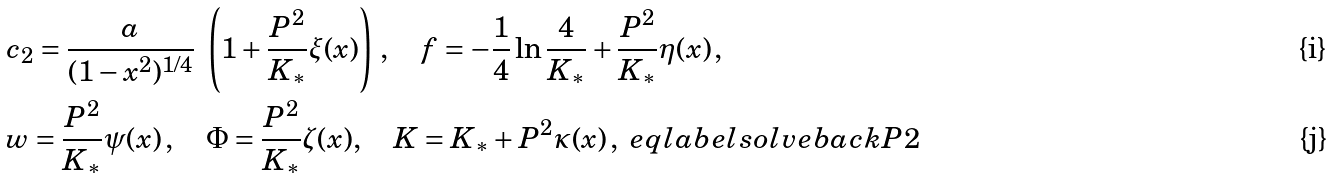<formula> <loc_0><loc_0><loc_500><loc_500>& c _ { 2 } = \frac { a } { ( 1 - x ^ { 2 } ) ^ { 1 / 4 } } \ \left ( 1 + \frac { P ^ { 2 } } { K _ { * } } \xi ( x ) \right ) \, , \quad f = - \frac { 1 } { 4 } \ln \frac { 4 } { K _ { * } } + \frac { P ^ { 2 } } { K _ { * } } \eta ( x ) \, , \\ & w = \frac { P ^ { 2 } } { K _ { * } } \psi ( x ) \, , \quad \Phi = \frac { P ^ { 2 } } { K _ { * } } \zeta ( x ) , \quad K = K _ { * } + P ^ { 2 } \kappa ( x ) \, , \ e q l a b e l { s o l v e b a c k P 2 }</formula> 